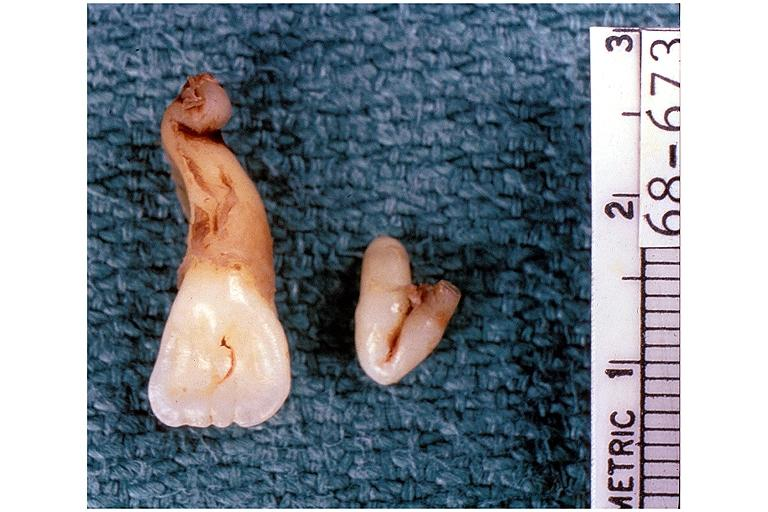s oral present?
Answer the question using a single word or phrase. Yes 